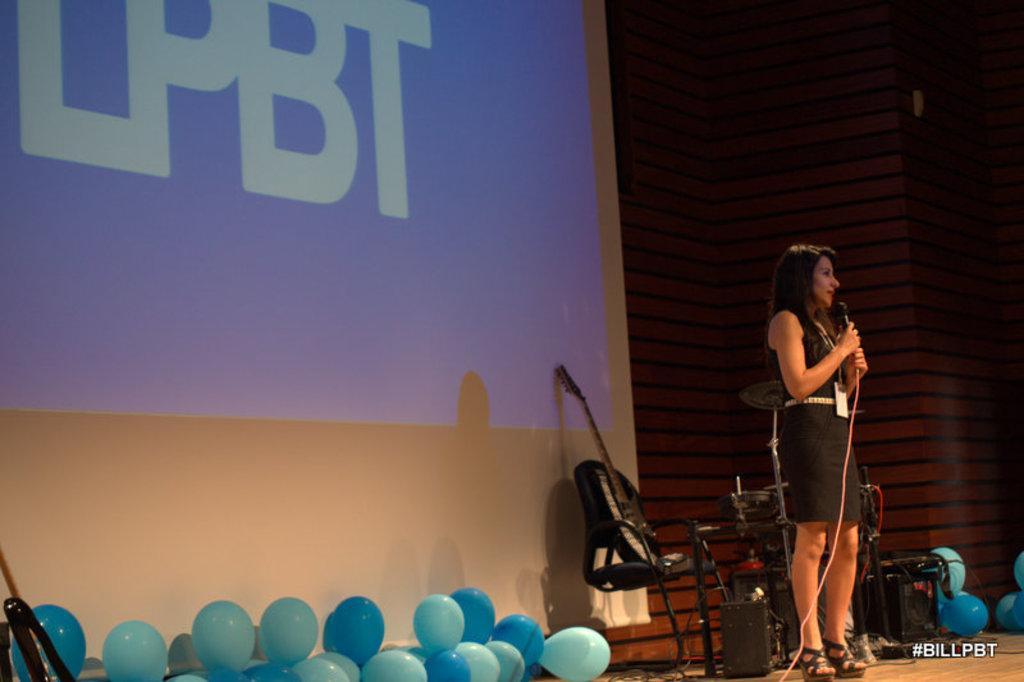How would you summarize this image in a sentence or two? This image is clicked in an Auditorium. There is a person standing on the right side. She is wearing black colour dress. She holding a mic in her hand, there is a guitar behind her on a chair. There are balloons in the bottom and there are speakers in the bottom. There is a screen on the left side. 